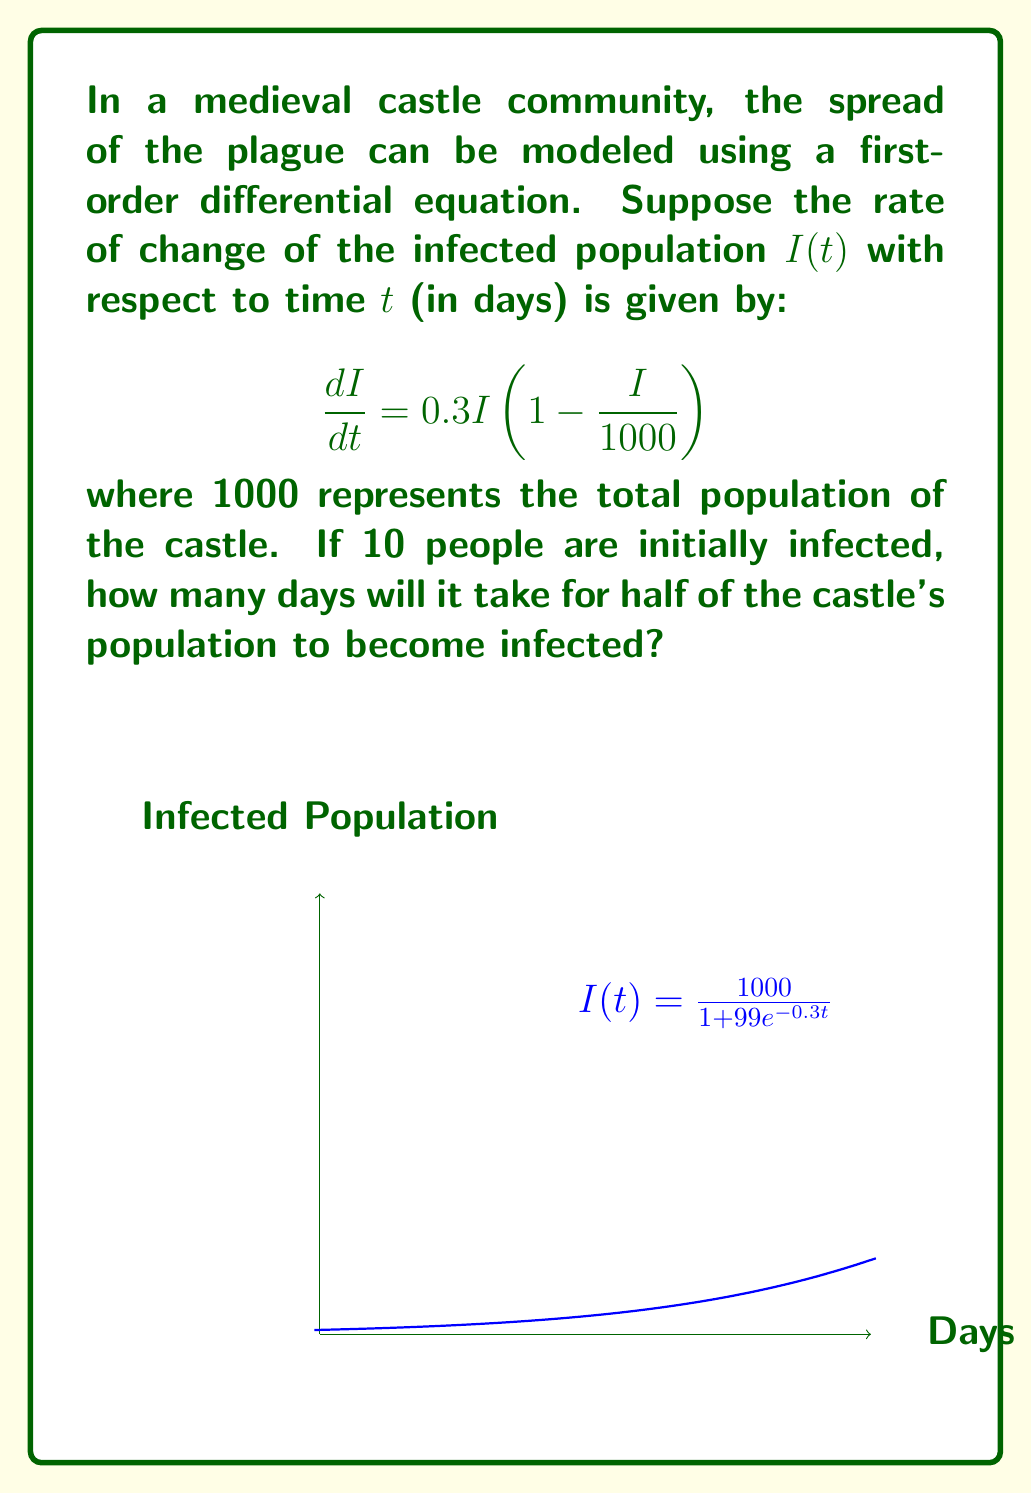Show me your answer to this math problem. To solve this problem, we need to follow these steps:

1) First, we recognize this as a logistic growth model with the solution:

   $$I(t) = \frac{K}{1 + Ce^{-rt}}$$

   where $K$ is the carrying capacity (1000 in this case), $r$ is the growth rate (0.3), and $C$ is a constant we need to determine.

2) We can find $C$ using the initial condition. When $t=0$, $I(0)=10$:

   $$10 = \frac{1000}{1 + C}$$

   Solving this, we get $C = 99$.

3) So our specific solution is:

   $$I(t) = \frac{1000}{1 + 99e^{-0.3t}}$$

4) We want to find when $I(t) = 500$ (half of the population):

   $$500 = \frac{1000}{1 + 99e^{-0.3t}}$$

5) Solving for $t$:

   $$1 + 99e^{-0.3t} = 2$$
   $$99e^{-0.3t} = 1$$
   $$e^{-0.3t} = \frac{1}{99}$$
   $$-0.3t = \ln(\frac{1}{99})$$
   $$t = -\frac{1}{0.3}\ln(\frac{1}{99}) \approx 15.35$$
Answer: Approximately 15.35 days 